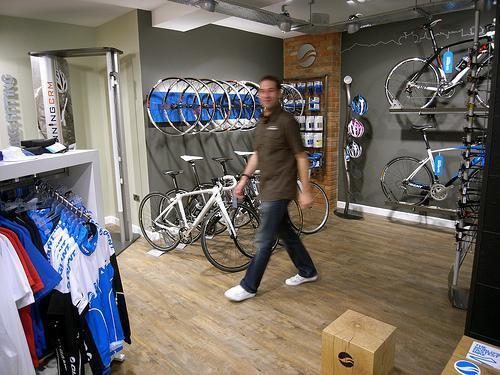How many bikes are hanging from the wall?
Give a very brief answer. 2. How many people are in the photo?
Give a very brief answer. 1. How many people are riding a bike?
Give a very brief answer. 0. 